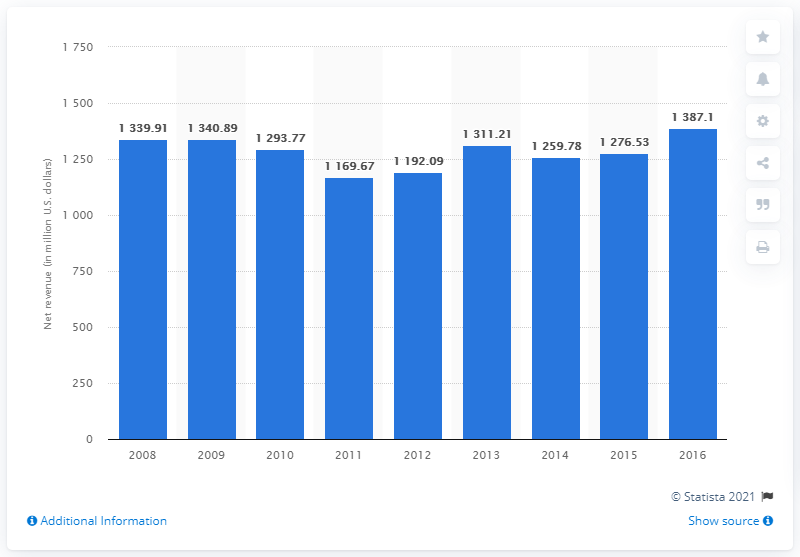Identify some key points in this picture. In 2011, Hasbro's net revenues from games and puzzles totaled $1,169.67. 